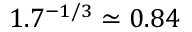<formula> <loc_0><loc_0><loc_500><loc_500>1 . 7 ^ { - 1 / 3 } \simeq 0 . 8 4</formula> 